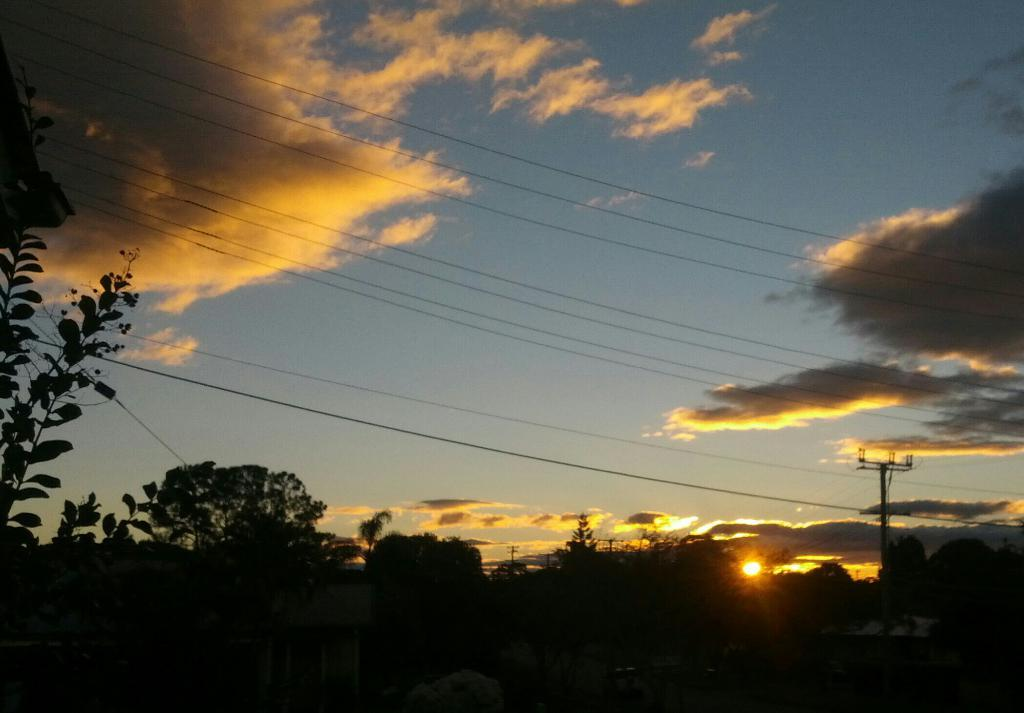What type of natural elements can be seen in the image? There are trees in the image. What man-made structures are visible in the background of the image? There are electric poles in the background of the image. How is the sun depicted in the image? The sun is visible in the image, with an orange and yellow color. What colors are present in the sky in the image? The sky is visible in the image, with a white and blue color. What type of bells can be heard ringing in the image? There are no bells present in the image, and therefore no sound can be heard. Can you tell me how many zebras are grazing in the image? There are no zebras present in the image; it features trees and electric poles. What type of canvas is used to create the image? The question about the canvas is irrelevant, as we are discussing the content of the image, not the medium or technique used to create it. 